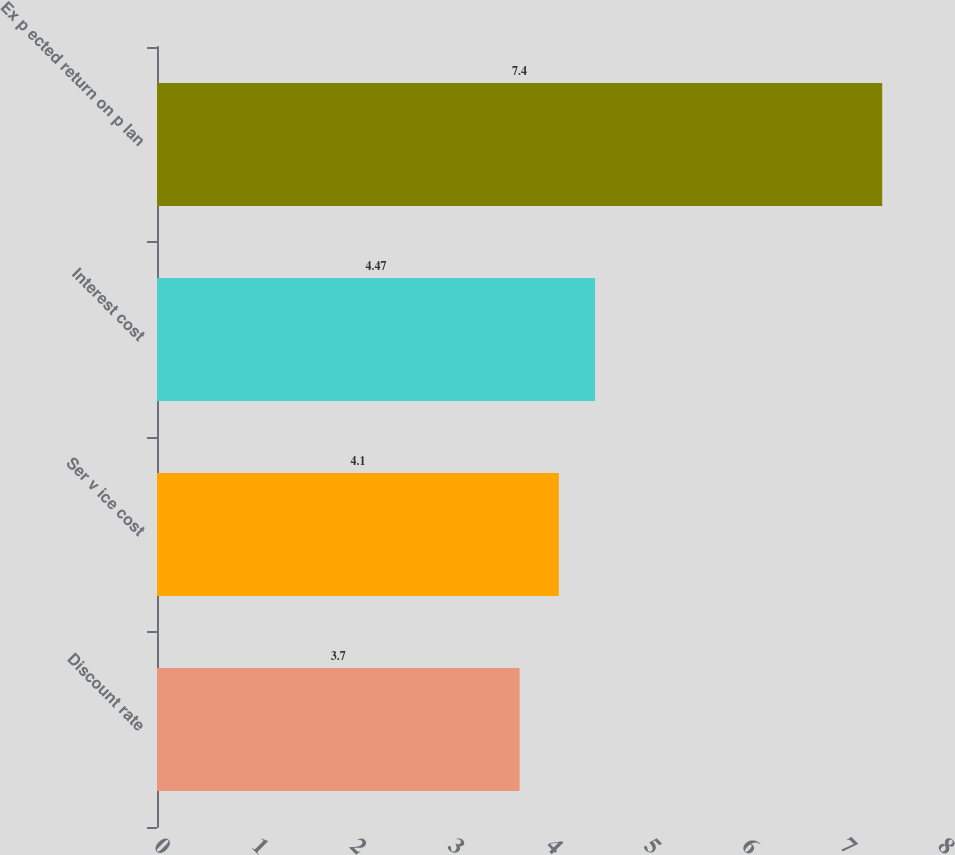<chart> <loc_0><loc_0><loc_500><loc_500><bar_chart><fcel>Discount rate<fcel>Ser v ice cost<fcel>Interest cost<fcel>Ex p ected return on p lan<nl><fcel>3.7<fcel>4.1<fcel>4.47<fcel>7.4<nl></chart> 